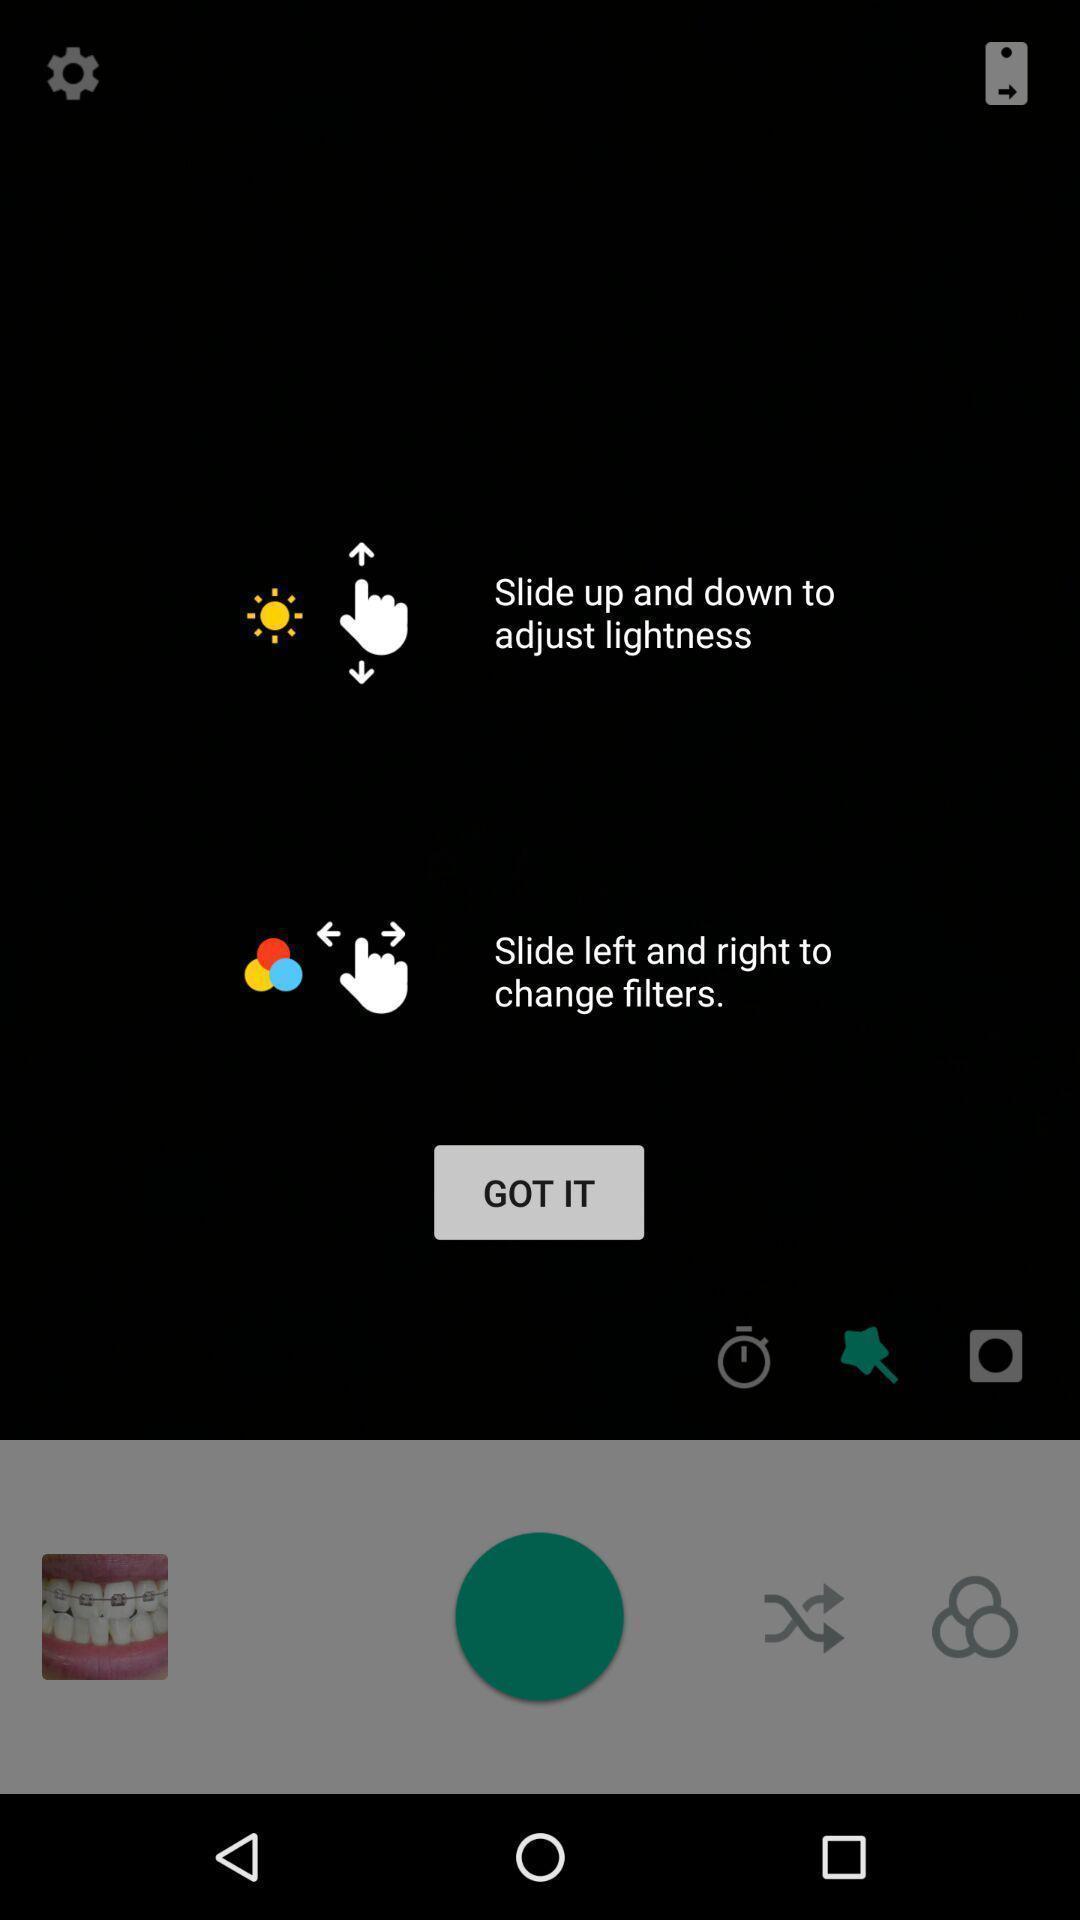Tell me about the visual elements in this screen capture. To change filters slide left and right for the app. 